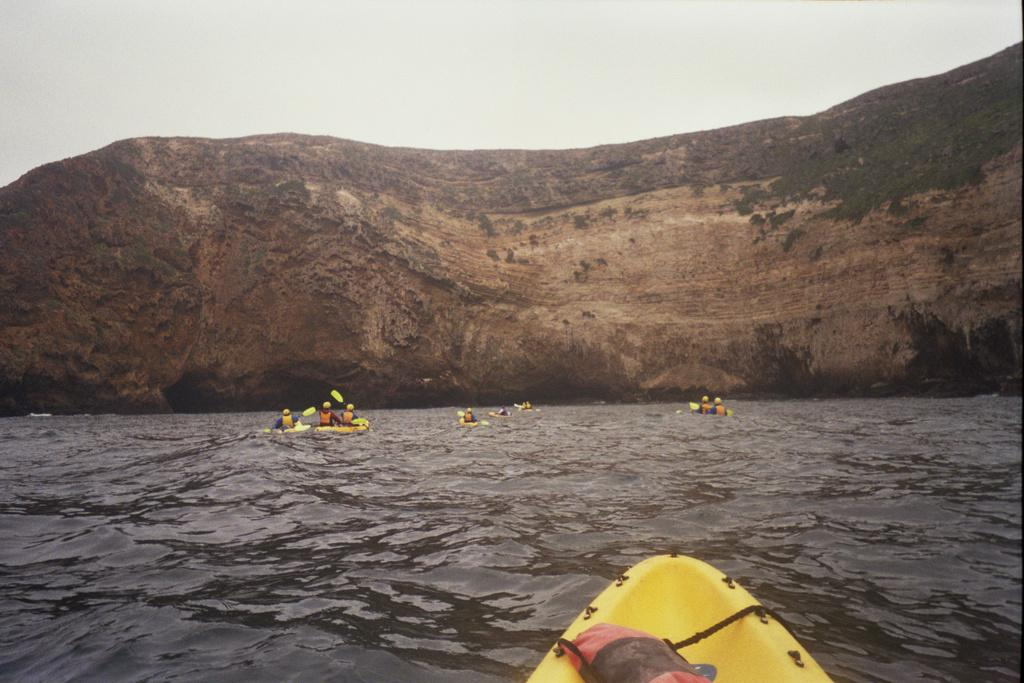What type of landscape feature is present in the image? There is a hill in the image. Who or what can be seen in the image besides the hill? There are people and watercraft visible in the image. What body of water is visible in the image? The sea is visible in the image. What else can be seen in the sky in the image? The sky is visible in the image. How many women are present in the image? There is no information about the gender of the people in the image, so it cannot be determined if there are any women present. 